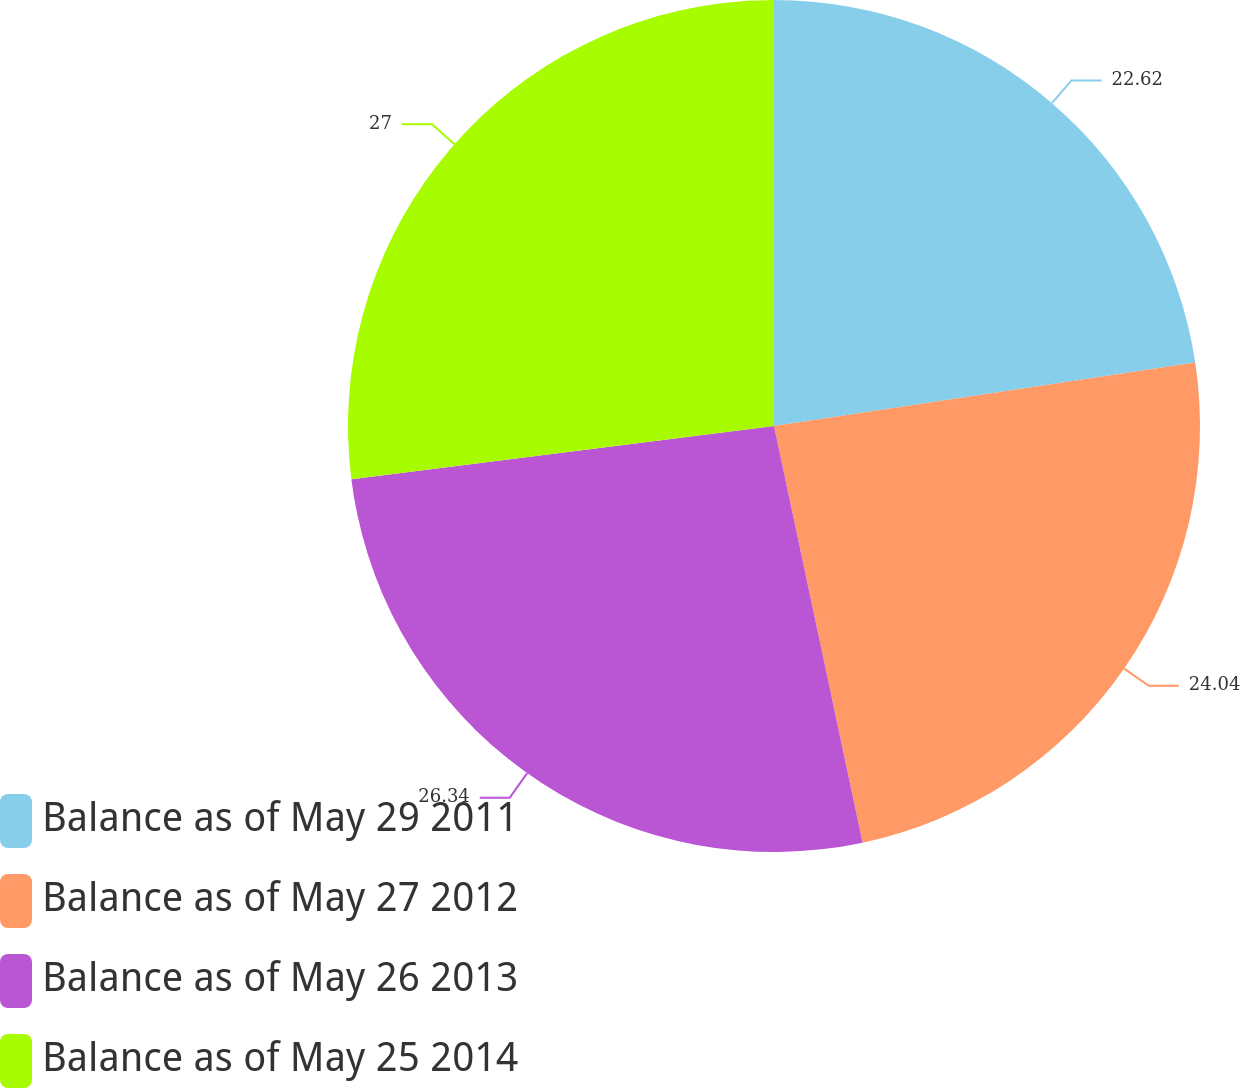Convert chart to OTSL. <chart><loc_0><loc_0><loc_500><loc_500><pie_chart><fcel>Balance as of May 29 2011<fcel>Balance as of May 27 2012<fcel>Balance as of May 26 2013<fcel>Balance as of May 25 2014<nl><fcel>22.62%<fcel>24.04%<fcel>26.34%<fcel>26.99%<nl></chart> 